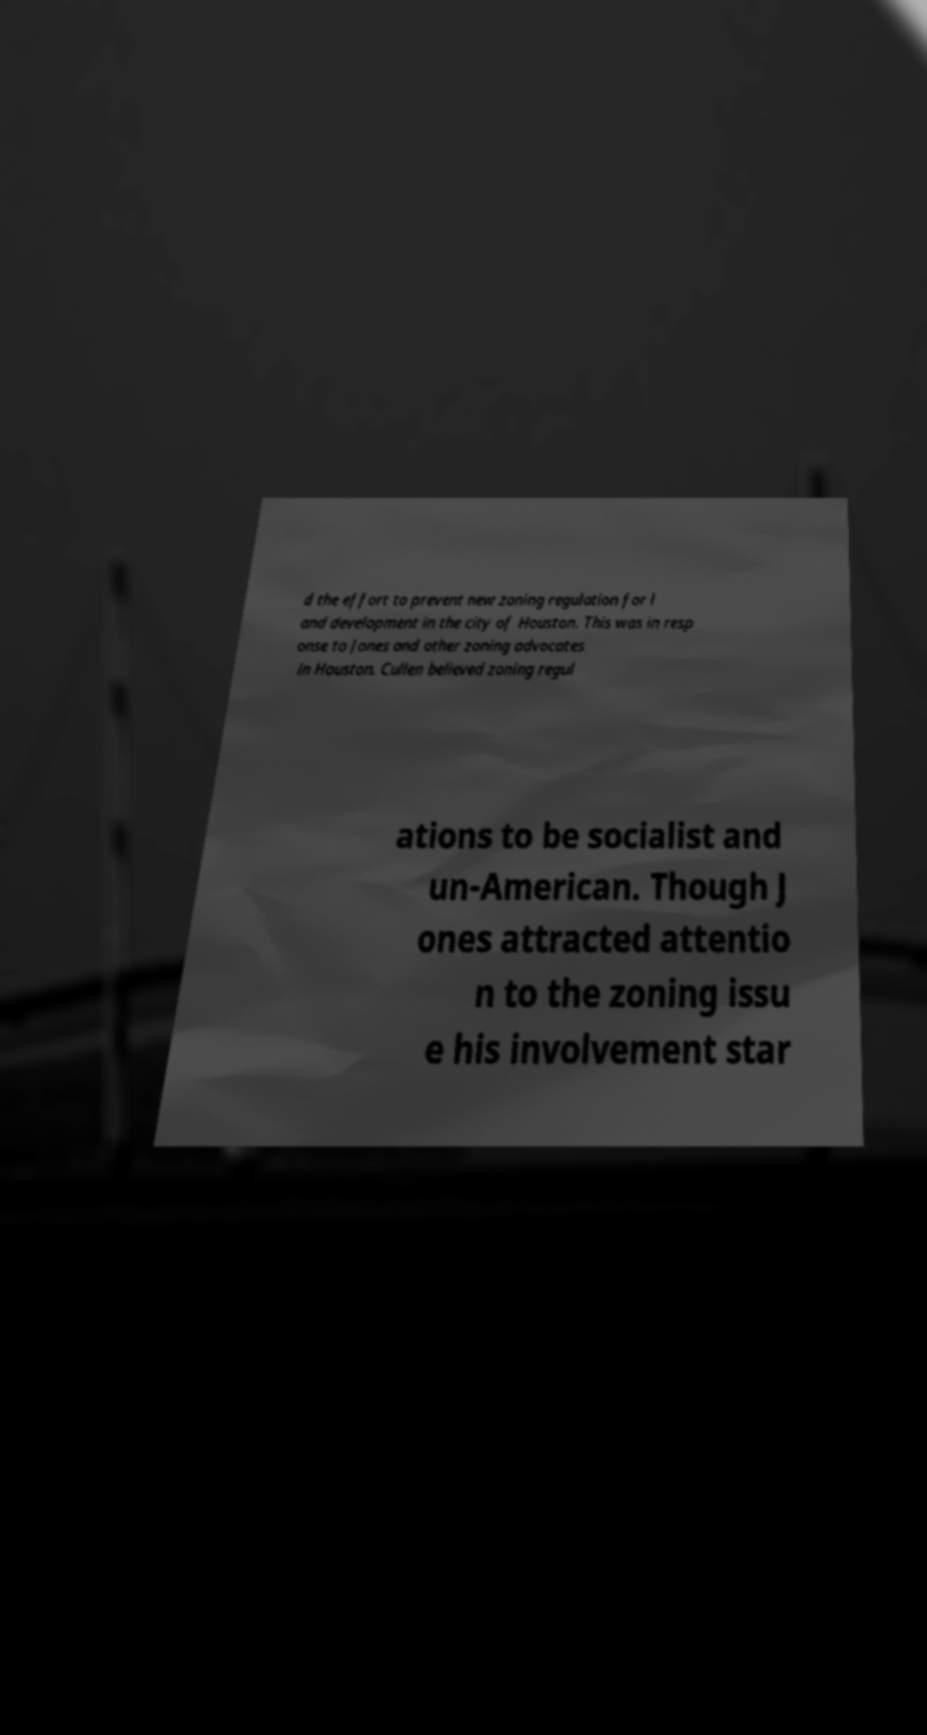For documentation purposes, I need the text within this image transcribed. Could you provide that? d the effort to prevent new zoning regulation for l and development in the city of Houston. This was in resp onse to Jones and other zoning advocates in Houston. Cullen believed zoning regul ations to be socialist and un-American. Though J ones attracted attentio n to the zoning issu e his involvement star 